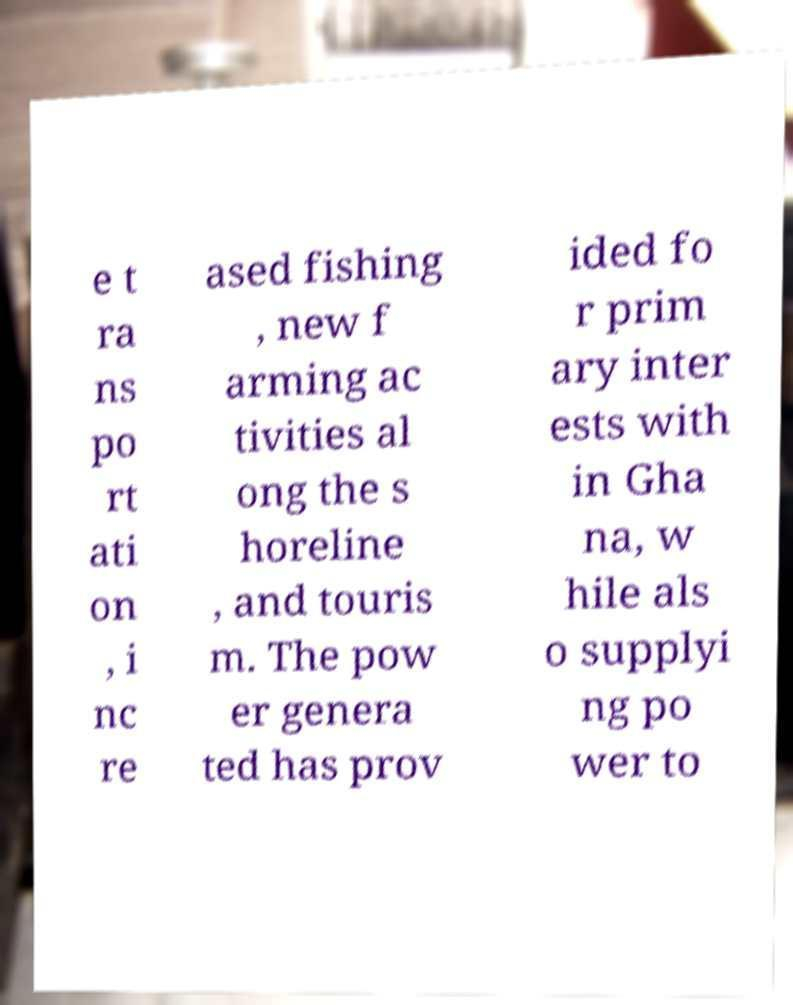Could you extract and type out the text from this image? e t ra ns po rt ati on , i nc re ased fishing , new f arming ac tivities al ong the s horeline , and touris m. The pow er genera ted has prov ided fo r prim ary inter ests with in Gha na, w hile als o supplyi ng po wer to 